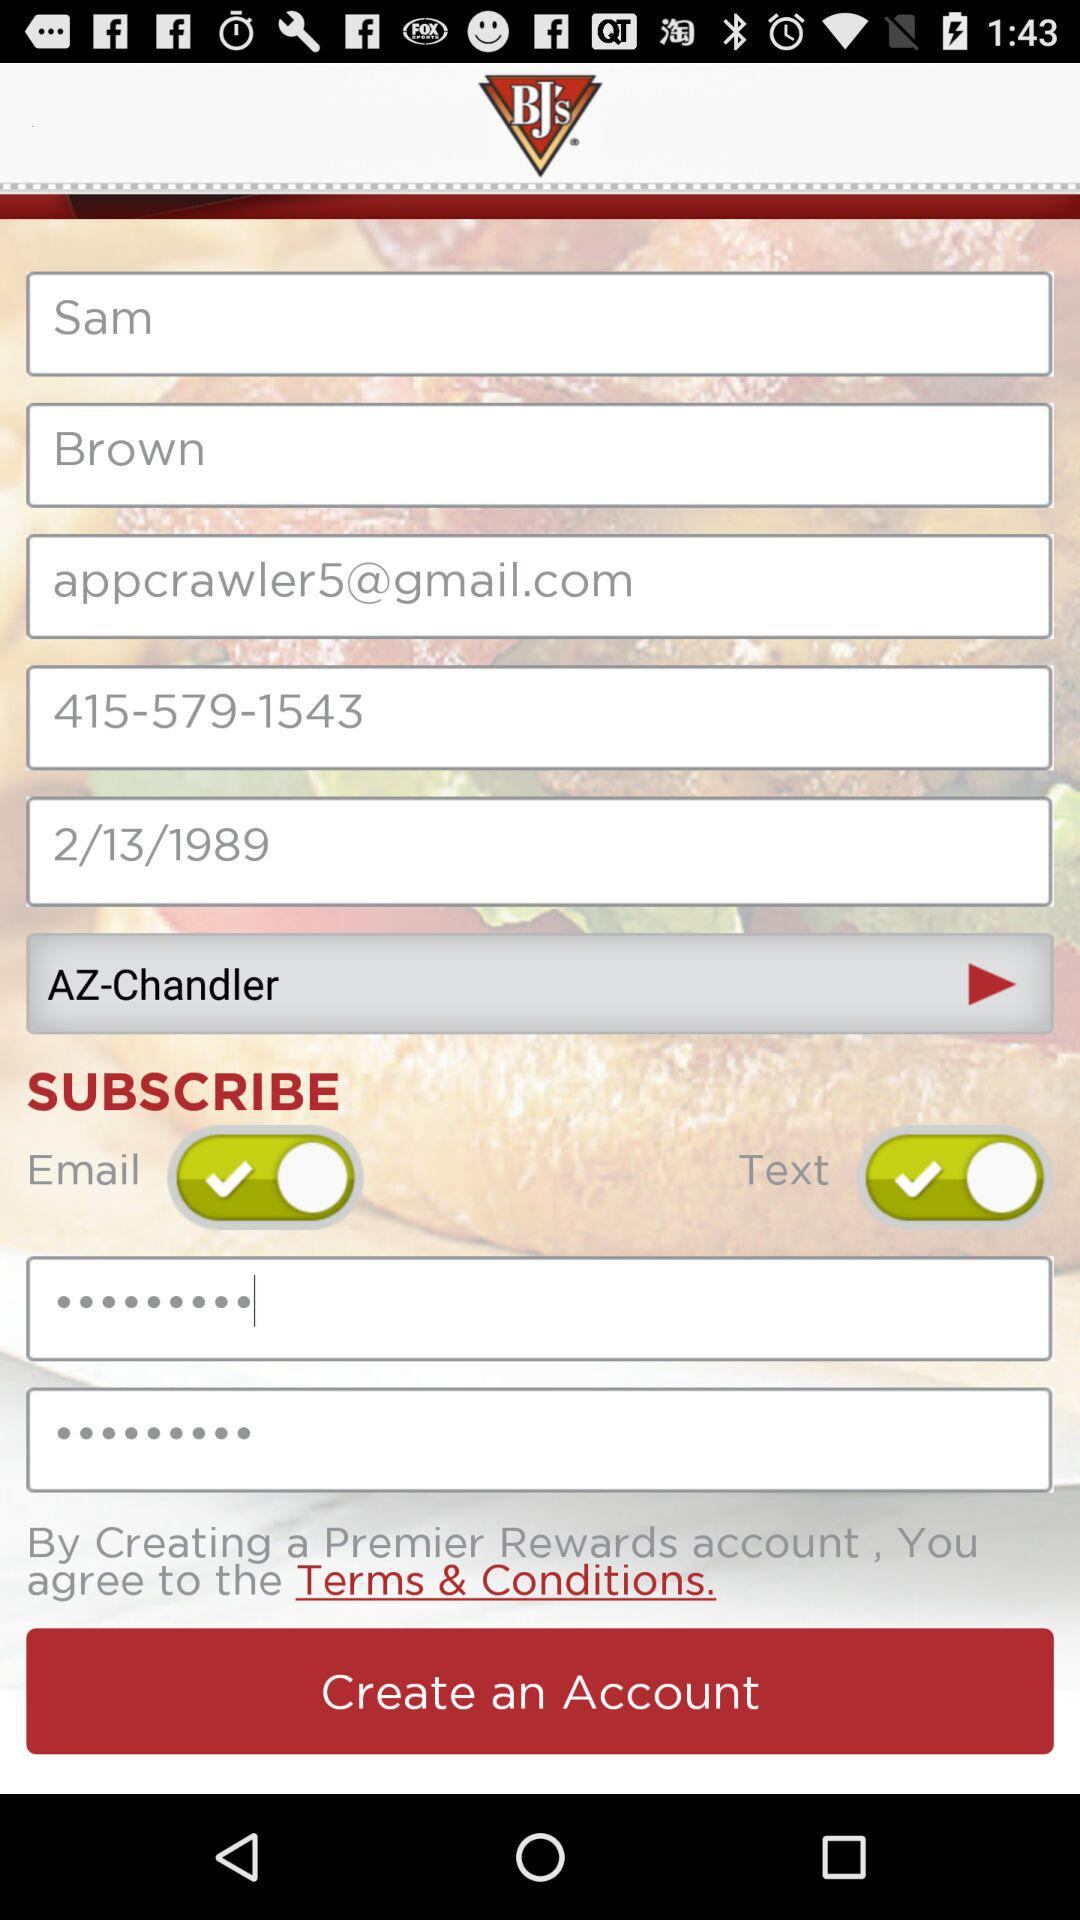What is the status of "Email"? The status of "Email" is "on". 